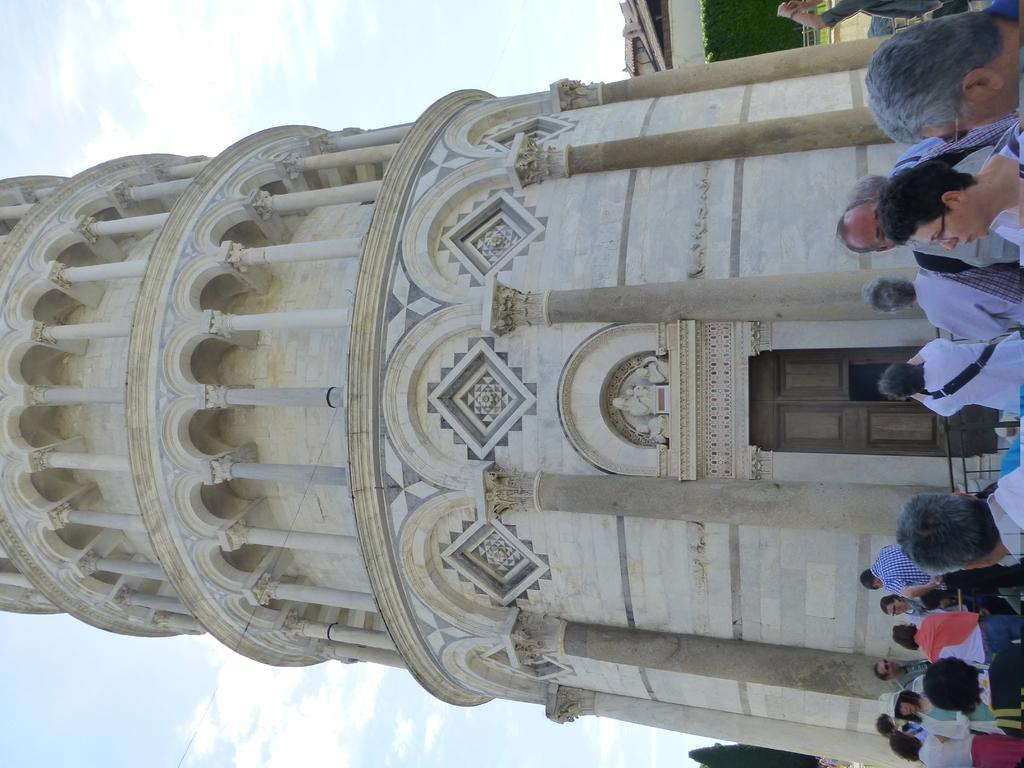How many people are in the image? There is a group of people standing in the image. What can be seen in the background of the image? There is a building in the image, and the sky is visible in the background. What is the color of the building? The building has a cream and white color. What is the color of the sky in the image? The sky is white in color. What type of jelly is being used to hold the building together in the image? There is no jelly present in the image, and it is not being used to hold the building together. 